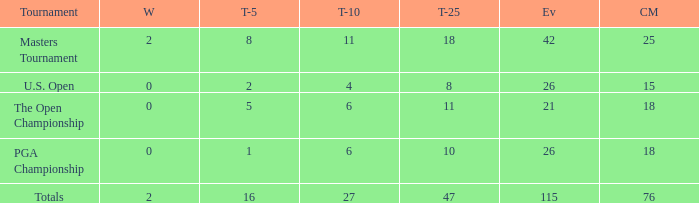When the wins are less than 0 and the Top-5 1 what is the average cuts? None. 